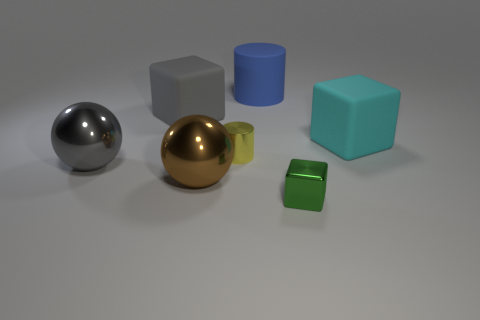How does the lighting in the image affect the appearance of the objects? The lighting in the image appears to be diffused, coming from above, casting soft shadows beneath the objects, which suggests a calm, evenly-lit indoor setting. This type of lighting allows for the materials' textures and colors to be more discernible, such as the reflective surfaces of the metallic spheres and the less reflective, matte surfaces of the cubes. 